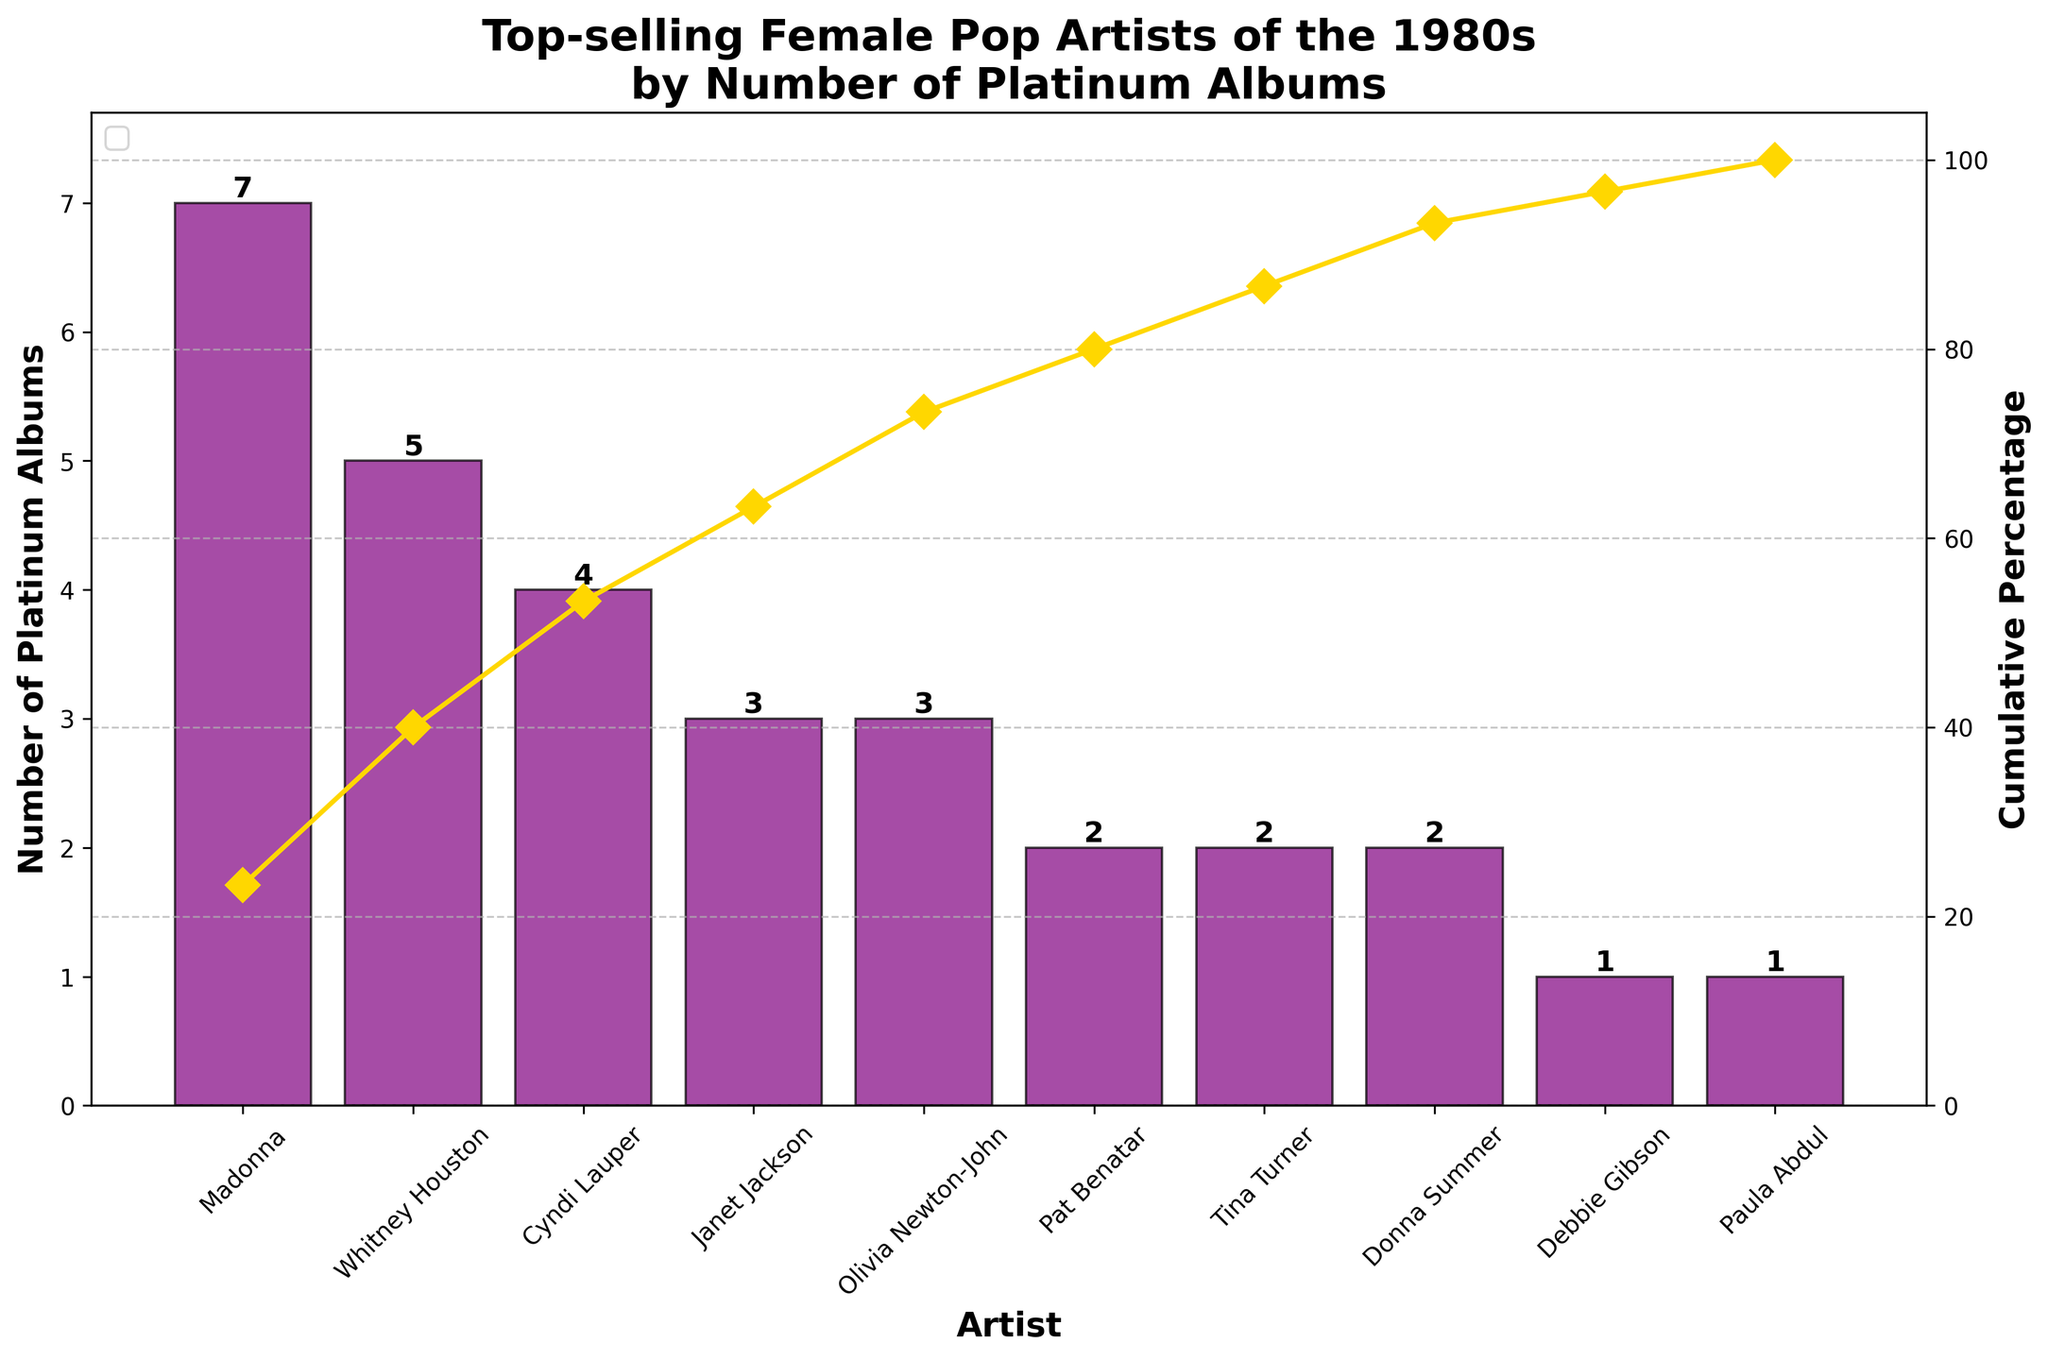1. How many platinum albums did Madonna have in the 1980s? Look at the bar corresponding to Madonna on the chart. The height of the bar indicates the number of platinum albums.
Answer: 7 2. Which two artists have the same number of platinum albums? Identify artists whose bars are equal in height. From the chart, Pat Benatar, Tina Turner, and Donna Summer all have bars of equal height.
Answer: Pat Benatar, Tina Turner, Donna Summer 3. What is the cumulative percentage after adding albums from Whitney Houston? Find Whitney Houston on the x-axis, then look at the cumulative percentage line above her bar.
Answer: 43.75% 4. Who follows Madonna in terms of the number of platinum albums? Look at the artist with the second-highest bar next to Madonna.
Answer: Whitney Houston 5. How many artists have more than three platinum albums? Count the number of bars higher than three on the y-axis.
Answer: 3 6. Who are the artists with three platinum albums? Look at the bars that reach the level of three on the y-axis.
Answer: Janet Jackson, Olivia Newton-John 7. What is the cumulative percentage after including the top three artists? Add the cumulative percentages for Madonna, Whitney Houston, and Cyndi Lauper from the chart.
Answer: 80% 8. How does the platinum album count drop after Cyndi Lauper? Compare the heights of the bars of Cyndi Lauper to the next highest bar.
Answer: Drops by 1 9. Which artist has the lowest number of platinum albums? Find the artist with the shortest bar on the chart.
Answer: Debbie Gibson, Paula Abdul 10. What is the percentage of platinum albums covered by the top artist alone? Look at the cumulative percentage above Madonna’s bar.
Answer: 35% 